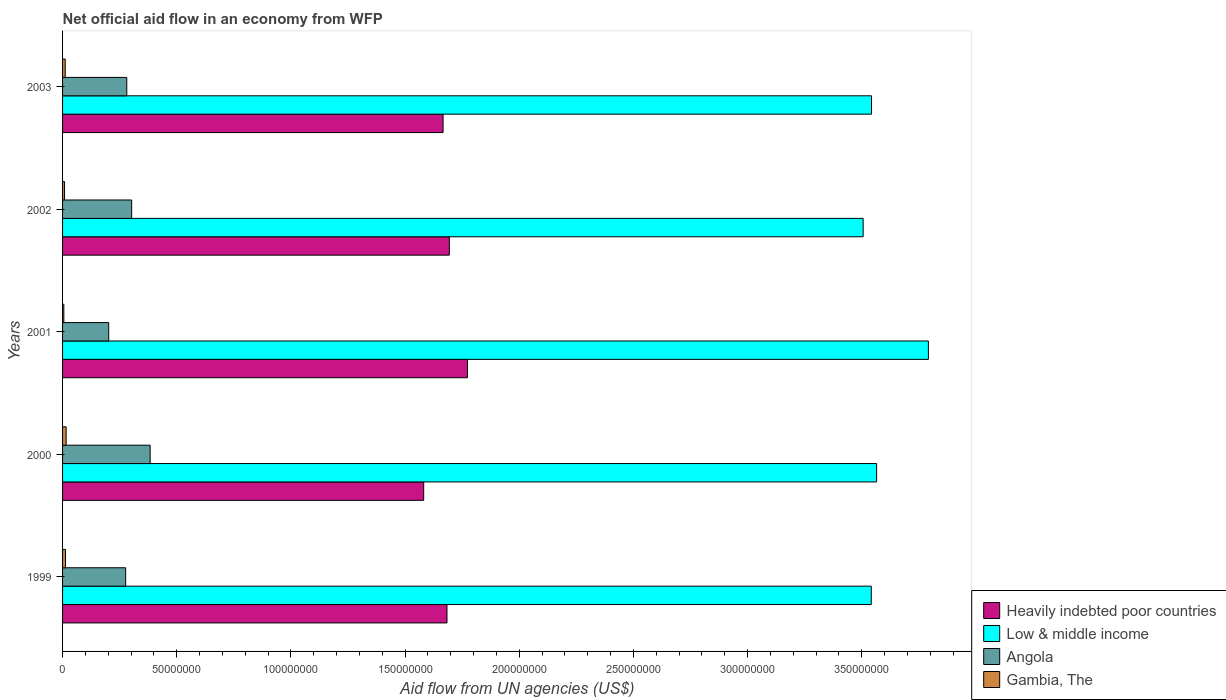How many different coloured bars are there?
Make the answer very short. 4. How many groups of bars are there?
Provide a succinct answer. 5. How many bars are there on the 4th tick from the bottom?
Offer a terse response. 4. In how many cases, is the number of bars for a given year not equal to the number of legend labels?
Your answer should be compact. 0. What is the net official aid flow in Angola in 2001?
Your answer should be very brief. 2.02e+07. Across all years, what is the maximum net official aid flow in Angola?
Give a very brief answer. 3.84e+07. Across all years, what is the minimum net official aid flow in Heavily indebted poor countries?
Your response must be concise. 1.58e+08. In which year was the net official aid flow in Gambia, The maximum?
Ensure brevity in your answer.  2000. In which year was the net official aid flow in Gambia, The minimum?
Provide a short and direct response. 2001. What is the total net official aid flow in Heavily indebted poor countries in the graph?
Offer a very short reply. 8.40e+08. What is the difference between the net official aid flow in Gambia, The in 2002 and that in 2003?
Offer a terse response. -3.00e+05. What is the difference between the net official aid flow in Angola in 2001 and the net official aid flow in Heavily indebted poor countries in 2003?
Give a very brief answer. -1.46e+08. What is the average net official aid flow in Heavily indebted poor countries per year?
Ensure brevity in your answer.  1.68e+08. In the year 2001, what is the difference between the net official aid flow in Heavily indebted poor countries and net official aid flow in Angola?
Your answer should be very brief. 1.57e+08. What is the ratio of the net official aid flow in Angola in 2000 to that in 2002?
Your answer should be compact. 1.27. Is the net official aid flow in Low & middle income in 1999 less than that in 2000?
Your answer should be compact. Yes. Is the difference between the net official aid flow in Heavily indebted poor countries in 1999 and 2002 greater than the difference between the net official aid flow in Angola in 1999 and 2002?
Provide a succinct answer. Yes. What is the difference between the highest and the second highest net official aid flow in Angola?
Your answer should be very brief. 8.10e+06. What is the difference between the highest and the lowest net official aid flow in Angola?
Give a very brief answer. 1.82e+07. In how many years, is the net official aid flow in Gambia, The greater than the average net official aid flow in Gambia, The taken over all years?
Keep it short and to the point. 3. Is the sum of the net official aid flow in Heavily indebted poor countries in 2001 and 2002 greater than the maximum net official aid flow in Low & middle income across all years?
Make the answer very short. No. Is it the case that in every year, the sum of the net official aid flow in Angola and net official aid flow in Gambia, The is greater than the sum of net official aid flow in Heavily indebted poor countries and net official aid flow in Low & middle income?
Your response must be concise. No. What does the 3rd bar from the top in 1999 represents?
Provide a succinct answer. Low & middle income. What does the 4th bar from the bottom in 2001 represents?
Give a very brief answer. Gambia, The. How many bars are there?
Provide a short and direct response. 20. Are all the bars in the graph horizontal?
Your answer should be very brief. Yes. How many years are there in the graph?
Your response must be concise. 5. Are the values on the major ticks of X-axis written in scientific E-notation?
Make the answer very short. No. Does the graph contain grids?
Offer a very short reply. No. Where does the legend appear in the graph?
Ensure brevity in your answer.  Bottom right. What is the title of the graph?
Provide a short and direct response. Net official aid flow in an economy from WFP. Does "Venezuela" appear as one of the legend labels in the graph?
Give a very brief answer. No. What is the label or title of the X-axis?
Your response must be concise. Aid flow from UN agencies (US$). What is the label or title of the Y-axis?
Ensure brevity in your answer.  Years. What is the Aid flow from UN agencies (US$) in Heavily indebted poor countries in 1999?
Offer a terse response. 1.68e+08. What is the Aid flow from UN agencies (US$) in Low & middle income in 1999?
Your answer should be compact. 3.54e+08. What is the Aid flow from UN agencies (US$) of Angola in 1999?
Offer a very short reply. 2.76e+07. What is the Aid flow from UN agencies (US$) of Gambia, The in 1999?
Offer a terse response. 1.29e+06. What is the Aid flow from UN agencies (US$) of Heavily indebted poor countries in 2000?
Provide a short and direct response. 1.58e+08. What is the Aid flow from UN agencies (US$) in Low & middle income in 2000?
Provide a short and direct response. 3.57e+08. What is the Aid flow from UN agencies (US$) in Angola in 2000?
Your response must be concise. 3.84e+07. What is the Aid flow from UN agencies (US$) of Gambia, The in 2000?
Your answer should be very brief. 1.56e+06. What is the Aid flow from UN agencies (US$) in Heavily indebted poor countries in 2001?
Provide a succinct answer. 1.77e+08. What is the Aid flow from UN agencies (US$) of Low & middle income in 2001?
Make the answer very short. 3.79e+08. What is the Aid flow from UN agencies (US$) of Angola in 2001?
Provide a short and direct response. 2.02e+07. What is the Aid flow from UN agencies (US$) in Gambia, The in 2001?
Make the answer very short. 5.60e+05. What is the Aid flow from UN agencies (US$) in Heavily indebted poor countries in 2002?
Give a very brief answer. 1.69e+08. What is the Aid flow from UN agencies (US$) of Low & middle income in 2002?
Ensure brevity in your answer.  3.51e+08. What is the Aid flow from UN agencies (US$) of Angola in 2002?
Your answer should be compact. 3.03e+07. What is the Aid flow from UN agencies (US$) in Gambia, The in 2002?
Your response must be concise. 8.70e+05. What is the Aid flow from UN agencies (US$) of Heavily indebted poor countries in 2003?
Ensure brevity in your answer.  1.67e+08. What is the Aid flow from UN agencies (US$) in Low & middle income in 2003?
Offer a very short reply. 3.54e+08. What is the Aid flow from UN agencies (US$) in Angola in 2003?
Provide a short and direct response. 2.81e+07. What is the Aid flow from UN agencies (US$) of Gambia, The in 2003?
Your response must be concise. 1.17e+06. Across all years, what is the maximum Aid flow from UN agencies (US$) in Heavily indebted poor countries?
Offer a very short reply. 1.77e+08. Across all years, what is the maximum Aid flow from UN agencies (US$) in Low & middle income?
Your answer should be very brief. 3.79e+08. Across all years, what is the maximum Aid flow from UN agencies (US$) of Angola?
Offer a very short reply. 3.84e+07. Across all years, what is the maximum Aid flow from UN agencies (US$) of Gambia, The?
Your answer should be compact. 1.56e+06. Across all years, what is the minimum Aid flow from UN agencies (US$) of Heavily indebted poor countries?
Ensure brevity in your answer.  1.58e+08. Across all years, what is the minimum Aid flow from UN agencies (US$) of Low & middle income?
Your answer should be very brief. 3.51e+08. Across all years, what is the minimum Aid flow from UN agencies (US$) of Angola?
Make the answer very short. 2.02e+07. Across all years, what is the minimum Aid flow from UN agencies (US$) in Gambia, The?
Your answer should be compact. 5.60e+05. What is the total Aid flow from UN agencies (US$) of Heavily indebted poor countries in the graph?
Your answer should be compact. 8.40e+08. What is the total Aid flow from UN agencies (US$) in Low & middle income in the graph?
Offer a terse response. 1.79e+09. What is the total Aid flow from UN agencies (US$) of Angola in the graph?
Give a very brief answer. 1.45e+08. What is the total Aid flow from UN agencies (US$) of Gambia, The in the graph?
Make the answer very short. 5.45e+06. What is the difference between the Aid flow from UN agencies (US$) of Heavily indebted poor countries in 1999 and that in 2000?
Your answer should be compact. 1.02e+07. What is the difference between the Aid flow from UN agencies (US$) of Low & middle income in 1999 and that in 2000?
Your response must be concise. -2.35e+06. What is the difference between the Aid flow from UN agencies (US$) in Angola in 1999 and that in 2000?
Give a very brief answer. -1.07e+07. What is the difference between the Aid flow from UN agencies (US$) in Gambia, The in 1999 and that in 2000?
Your response must be concise. -2.70e+05. What is the difference between the Aid flow from UN agencies (US$) of Heavily indebted poor countries in 1999 and that in 2001?
Your answer should be compact. -8.98e+06. What is the difference between the Aid flow from UN agencies (US$) of Low & middle income in 1999 and that in 2001?
Your answer should be very brief. -2.50e+07. What is the difference between the Aid flow from UN agencies (US$) in Angola in 1999 and that in 2001?
Your response must be concise. 7.41e+06. What is the difference between the Aid flow from UN agencies (US$) of Gambia, The in 1999 and that in 2001?
Your answer should be very brief. 7.30e+05. What is the difference between the Aid flow from UN agencies (US$) of Heavily indebted poor countries in 1999 and that in 2002?
Keep it short and to the point. -1.03e+06. What is the difference between the Aid flow from UN agencies (US$) of Low & middle income in 1999 and that in 2002?
Keep it short and to the point. 3.56e+06. What is the difference between the Aid flow from UN agencies (US$) in Angola in 1999 and that in 2002?
Your response must be concise. -2.64e+06. What is the difference between the Aid flow from UN agencies (US$) in Gambia, The in 1999 and that in 2002?
Offer a very short reply. 4.20e+05. What is the difference between the Aid flow from UN agencies (US$) in Heavily indebted poor countries in 1999 and that in 2003?
Provide a succinct answer. 1.71e+06. What is the difference between the Aid flow from UN agencies (US$) in Angola in 1999 and that in 2003?
Keep it short and to the point. -5.00e+05. What is the difference between the Aid flow from UN agencies (US$) of Gambia, The in 1999 and that in 2003?
Offer a very short reply. 1.20e+05. What is the difference between the Aid flow from UN agencies (US$) in Heavily indebted poor countries in 2000 and that in 2001?
Keep it short and to the point. -1.92e+07. What is the difference between the Aid flow from UN agencies (US$) of Low & middle income in 2000 and that in 2001?
Provide a succinct answer. -2.27e+07. What is the difference between the Aid flow from UN agencies (US$) of Angola in 2000 and that in 2001?
Keep it short and to the point. 1.82e+07. What is the difference between the Aid flow from UN agencies (US$) in Heavily indebted poor countries in 2000 and that in 2002?
Your answer should be compact. -1.12e+07. What is the difference between the Aid flow from UN agencies (US$) of Low & middle income in 2000 and that in 2002?
Your answer should be compact. 5.91e+06. What is the difference between the Aid flow from UN agencies (US$) of Angola in 2000 and that in 2002?
Give a very brief answer. 8.10e+06. What is the difference between the Aid flow from UN agencies (US$) in Gambia, The in 2000 and that in 2002?
Keep it short and to the point. 6.90e+05. What is the difference between the Aid flow from UN agencies (US$) in Heavily indebted poor countries in 2000 and that in 2003?
Ensure brevity in your answer.  -8.49e+06. What is the difference between the Aid flow from UN agencies (US$) in Low & middle income in 2000 and that in 2003?
Your response must be concise. 2.24e+06. What is the difference between the Aid flow from UN agencies (US$) of Angola in 2000 and that in 2003?
Your answer should be compact. 1.02e+07. What is the difference between the Aid flow from UN agencies (US$) of Gambia, The in 2000 and that in 2003?
Your answer should be very brief. 3.90e+05. What is the difference between the Aid flow from UN agencies (US$) of Heavily indebted poor countries in 2001 and that in 2002?
Provide a succinct answer. 7.95e+06. What is the difference between the Aid flow from UN agencies (US$) of Low & middle income in 2001 and that in 2002?
Offer a terse response. 2.86e+07. What is the difference between the Aid flow from UN agencies (US$) of Angola in 2001 and that in 2002?
Provide a succinct answer. -1.00e+07. What is the difference between the Aid flow from UN agencies (US$) in Gambia, The in 2001 and that in 2002?
Provide a short and direct response. -3.10e+05. What is the difference between the Aid flow from UN agencies (US$) in Heavily indebted poor countries in 2001 and that in 2003?
Provide a short and direct response. 1.07e+07. What is the difference between the Aid flow from UN agencies (US$) in Low & middle income in 2001 and that in 2003?
Provide a succinct answer. 2.49e+07. What is the difference between the Aid flow from UN agencies (US$) of Angola in 2001 and that in 2003?
Give a very brief answer. -7.91e+06. What is the difference between the Aid flow from UN agencies (US$) in Gambia, The in 2001 and that in 2003?
Your answer should be compact. -6.10e+05. What is the difference between the Aid flow from UN agencies (US$) of Heavily indebted poor countries in 2002 and that in 2003?
Offer a terse response. 2.74e+06. What is the difference between the Aid flow from UN agencies (US$) of Low & middle income in 2002 and that in 2003?
Ensure brevity in your answer.  -3.67e+06. What is the difference between the Aid flow from UN agencies (US$) of Angola in 2002 and that in 2003?
Your answer should be very brief. 2.14e+06. What is the difference between the Aid flow from UN agencies (US$) of Gambia, The in 2002 and that in 2003?
Ensure brevity in your answer.  -3.00e+05. What is the difference between the Aid flow from UN agencies (US$) in Heavily indebted poor countries in 1999 and the Aid flow from UN agencies (US$) in Low & middle income in 2000?
Your answer should be compact. -1.88e+08. What is the difference between the Aid flow from UN agencies (US$) in Heavily indebted poor countries in 1999 and the Aid flow from UN agencies (US$) in Angola in 2000?
Provide a succinct answer. 1.30e+08. What is the difference between the Aid flow from UN agencies (US$) in Heavily indebted poor countries in 1999 and the Aid flow from UN agencies (US$) in Gambia, The in 2000?
Your answer should be compact. 1.67e+08. What is the difference between the Aid flow from UN agencies (US$) of Low & middle income in 1999 and the Aid flow from UN agencies (US$) of Angola in 2000?
Give a very brief answer. 3.16e+08. What is the difference between the Aid flow from UN agencies (US$) in Low & middle income in 1999 and the Aid flow from UN agencies (US$) in Gambia, The in 2000?
Keep it short and to the point. 3.53e+08. What is the difference between the Aid flow from UN agencies (US$) of Angola in 1999 and the Aid flow from UN agencies (US$) of Gambia, The in 2000?
Offer a very short reply. 2.61e+07. What is the difference between the Aid flow from UN agencies (US$) of Heavily indebted poor countries in 1999 and the Aid flow from UN agencies (US$) of Low & middle income in 2001?
Offer a very short reply. -2.11e+08. What is the difference between the Aid flow from UN agencies (US$) of Heavily indebted poor countries in 1999 and the Aid flow from UN agencies (US$) of Angola in 2001?
Provide a short and direct response. 1.48e+08. What is the difference between the Aid flow from UN agencies (US$) of Heavily indebted poor countries in 1999 and the Aid flow from UN agencies (US$) of Gambia, The in 2001?
Your response must be concise. 1.68e+08. What is the difference between the Aid flow from UN agencies (US$) of Low & middle income in 1999 and the Aid flow from UN agencies (US$) of Angola in 2001?
Keep it short and to the point. 3.34e+08. What is the difference between the Aid flow from UN agencies (US$) of Low & middle income in 1999 and the Aid flow from UN agencies (US$) of Gambia, The in 2001?
Offer a very short reply. 3.54e+08. What is the difference between the Aid flow from UN agencies (US$) in Angola in 1999 and the Aid flow from UN agencies (US$) in Gambia, The in 2001?
Your answer should be compact. 2.71e+07. What is the difference between the Aid flow from UN agencies (US$) of Heavily indebted poor countries in 1999 and the Aid flow from UN agencies (US$) of Low & middle income in 2002?
Your response must be concise. -1.82e+08. What is the difference between the Aid flow from UN agencies (US$) in Heavily indebted poor countries in 1999 and the Aid flow from UN agencies (US$) in Angola in 2002?
Give a very brief answer. 1.38e+08. What is the difference between the Aid flow from UN agencies (US$) of Heavily indebted poor countries in 1999 and the Aid flow from UN agencies (US$) of Gambia, The in 2002?
Offer a very short reply. 1.67e+08. What is the difference between the Aid flow from UN agencies (US$) of Low & middle income in 1999 and the Aid flow from UN agencies (US$) of Angola in 2002?
Ensure brevity in your answer.  3.24e+08. What is the difference between the Aid flow from UN agencies (US$) in Low & middle income in 1999 and the Aid flow from UN agencies (US$) in Gambia, The in 2002?
Provide a succinct answer. 3.53e+08. What is the difference between the Aid flow from UN agencies (US$) in Angola in 1999 and the Aid flow from UN agencies (US$) in Gambia, The in 2002?
Make the answer very short. 2.68e+07. What is the difference between the Aid flow from UN agencies (US$) in Heavily indebted poor countries in 1999 and the Aid flow from UN agencies (US$) in Low & middle income in 2003?
Your answer should be compact. -1.86e+08. What is the difference between the Aid flow from UN agencies (US$) in Heavily indebted poor countries in 1999 and the Aid flow from UN agencies (US$) in Angola in 2003?
Offer a very short reply. 1.40e+08. What is the difference between the Aid flow from UN agencies (US$) of Heavily indebted poor countries in 1999 and the Aid flow from UN agencies (US$) of Gambia, The in 2003?
Provide a succinct answer. 1.67e+08. What is the difference between the Aid flow from UN agencies (US$) in Low & middle income in 1999 and the Aid flow from UN agencies (US$) in Angola in 2003?
Keep it short and to the point. 3.26e+08. What is the difference between the Aid flow from UN agencies (US$) of Low & middle income in 1999 and the Aid flow from UN agencies (US$) of Gambia, The in 2003?
Offer a very short reply. 3.53e+08. What is the difference between the Aid flow from UN agencies (US$) in Angola in 1999 and the Aid flow from UN agencies (US$) in Gambia, The in 2003?
Your answer should be very brief. 2.64e+07. What is the difference between the Aid flow from UN agencies (US$) in Heavily indebted poor countries in 2000 and the Aid flow from UN agencies (US$) in Low & middle income in 2001?
Provide a succinct answer. -2.21e+08. What is the difference between the Aid flow from UN agencies (US$) of Heavily indebted poor countries in 2000 and the Aid flow from UN agencies (US$) of Angola in 2001?
Offer a terse response. 1.38e+08. What is the difference between the Aid flow from UN agencies (US$) in Heavily indebted poor countries in 2000 and the Aid flow from UN agencies (US$) in Gambia, The in 2001?
Give a very brief answer. 1.58e+08. What is the difference between the Aid flow from UN agencies (US$) in Low & middle income in 2000 and the Aid flow from UN agencies (US$) in Angola in 2001?
Provide a succinct answer. 3.36e+08. What is the difference between the Aid flow from UN agencies (US$) of Low & middle income in 2000 and the Aid flow from UN agencies (US$) of Gambia, The in 2001?
Offer a very short reply. 3.56e+08. What is the difference between the Aid flow from UN agencies (US$) of Angola in 2000 and the Aid flow from UN agencies (US$) of Gambia, The in 2001?
Your answer should be very brief. 3.78e+07. What is the difference between the Aid flow from UN agencies (US$) in Heavily indebted poor countries in 2000 and the Aid flow from UN agencies (US$) in Low & middle income in 2002?
Ensure brevity in your answer.  -1.92e+08. What is the difference between the Aid flow from UN agencies (US$) in Heavily indebted poor countries in 2000 and the Aid flow from UN agencies (US$) in Angola in 2002?
Provide a succinct answer. 1.28e+08. What is the difference between the Aid flow from UN agencies (US$) of Heavily indebted poor countries in 2000 and the Aid flow from UN agencies (US$) of Gambia, The in 2002?
Offer a very short reply. 1.57e+08. What is the difference between the Aid flow from UN agencies (US$) of Low & middle income in 2000 and the Aid flow from UN agencies (US$) of Angola in 2002?
Ensure brevity in your answer.  3.26e+08. What is the difference between the Aid flow from UN agencies (US$) of Low & middle income in 2000 and the Aid flow from UN agencies (US$) of Gambia, The in 2002?
Your answer should be very brief. 3.56e+08. What is the difference between the Aid flow from UN agencies (US$) in Angola in 2000 and the Aid flow from UN agencies (US$) in Gambia, The in 2002?
Give a very brief answer. 3.75e+07. What is the difference between the Aid flow from UN agencies (US$) of Heavily indebted poor countries in 2000 and the Aid flow from UN agencies (US$) of Low & middle income in 2003?
Your response must be concise. -1.96e+08. What is the difference between the Aid flow from UN agencies (US$) in Heavily indebted poor countries in 2000 and the Aid flow from UN agencies (US$) in Angola in 2003?
Make the answer very short. 1.30e+08. What is the difference between the Aid flow from UN agencies (US$) in Heavily indebted poor countries in 2000 and the Aid flow from UN agencies (US$) in Gambia, The in 2003?
Offer a very short reply. 1.57e+08. What is the difference between the Aid flow from UN agencies (US$) of Low & middle income in 2000 and the Aid flow from UN agencies (US$) of Angola in 2003?
Keep it short and to the point. 3.28e+08. What is the difference between the Aid flow from UN agencies (US$) of Low & middle income in 2000 and the Aid flow from UN agencies (US$) of Gambia, The in 2003?
Give a very brief answer. 3.55e+08. What is the difference between the Aid flow from UN agencies (US$) in Angola in 2000 and the Aid flow from UN agencies (US$) in Gambia, The in 2003?
Provide a short and direct response. 3.72e+07. What is the difference between the Aid flow from UN agencies (US$) of Heavily indebted poor countries in 2001 and the Aid flow from UN agencies (US$) of Low & middle income in 2002?
Make the answer very short. -1.73e+08. What is the difference between the Aid flow from UN agencies (US$) in Heavily indebted poor countries in 2001 and the Aid flow from UN agencies (US$) in Angola in 2002?
Offer a very short reply. 1.47e+08. What is the difference between the Aid flow from UN agencies (US$) in Heavily indebted poor countries in 2001 and the Aid flow from UN agencies (US$) in Gambia, The in 2002?
Give a very brief answer. 1.76e+08. What is the difference between the Aid flow from UN agencies (US$) of Low & middle income in 2001 and the Aid flow from UN agencies (US$) of Angola in 2002?
Provide a succinct answer. 3.49e+08. What is the difference between the Aid flow from UN agencies (US$) of Low & middle income in 2001 and the Aid flow from UN agencies (US$) of Gambia, The in 2002?
Your answer should be very brief. 3.78e+08. What is the difference between the Aid flow from UN agencies (US$) of Angola in 2001 and the Aid flow from UN agencies (US$) of Gambia, The in 2002?
Offer a terse response. 1.93e+07. What is the difference between the Aid flow from UN agencies (US$) in Heavily indebted poor countries in 2001 and the Aid flow from UN agencies (US$) in Low & middle income in 2003?
Offer a terse response. -1.77e+08. What is the difference between the Aid flow from UN agencies (US$) of Heavily indebted poor countries in 2001 and the Aid flow from UN agencies (US$) of Angola in 2003?
Give a very brief answer. 1.49e+08. What is the difference between the Aid flow from UN agencies (US$) in Heavily indebted poor countries in 2001 and the Aid flow from UN agencies (US$) in Gambia, The in 2003?
Give a very brief answer. 1.76e+08. What is the difference between the Aid flow from UN agencies (US$) in Low & middle income in 2001 and the Aid flow from UN agencies (US$) in Angola in 2003?
Provide a succinct answer. 3.51e+08. What is the difference between the Aid flow from UN agencies (US$) of Low & middle income in 2001 and the Aid flow from UN agencies (US$) of Gambia, The in 2003?
Your answer should be compact. 3.78e+08. What is the difference between the Aid flow from UN agencies (US$) of Angola in 2001 and the Aid flow from UN agencies (US$) of Gambia, The in 2003?
Ensure brevity in your answer.  1.90e+07. What is the difference between the Aid flow from UN agencies (US$) of Heavily indebted poor countries in 2002 and the Aid flow from UN agencies (US$) of Low & middle income in 2003?
Your response must be concise. -1.85e+08. What is the difference between the Aid flow from UN agencies (US$) of Heavily indebted poor countries in 2002 and the Aid flow from UN agencies (US$) of Angola in 2003?
Your answer should be very brief. 1.41e+08. What is the difference between the Aid flow from UN agencies (US$) in Heavily indebted poor countries in 2002 and the Aid flow from UN agencies (US$) in Gambia, The in 2003?
Offer a terse response. 1.68e+08. What is the difference between the Aid flow from UN agencies (US$) in Low & middle income in 2002 and the Aid flow from UN agencies (US$) in Angola in 2003?
Provide a short and direct response. 3.22e+08. What is the difference between the Aid flow from UN agencies (US$) in Low & middle income in 2002 and the Aid flow from UN agencies (US$) in Gambia, The in 2003?
Ensure brevity in your answer.  3.49e+08. What is the difference between the Aid flow from UN agencies (US$) in Angola in 2002 and the Aid flow from UN agencies (US$) in Gambia, The in 2003?
Your response must be concise. 2.91e+07. What is the average Aid flow from UN agencies (US$) in Heavily indebted poor countries per year?
Make the answer very short. 1.68e+08. What is the average Aid flow from UN agencies (US$) of Low & middle income per year?
Keep it short and to the point. 3.59e+08. What is the average Aid flow from UN agencies (US$) in Angola per year?
Ensure brevity in your answer.  2.89e+07. What is the average Aid flow from UN agencies (US$) of Gambia, The per year?
Offer a terse response. 1.09e+06. In the year 1999, what is the difference between the Aid flow from UN agencies (US$) of Heavily indebted poor countries and Aid flow from UN agencies (US$) of Low & middle income?
Ensure brevity in your answer.  -1.86e+08. In the year 1999, what is the difference between the Aid flow from UN agencies (US$) in Heavily indebted poor countries and Aid flow from UN agencies (US$) in Angola?
Offer a very short reply. 1.41e+08. In the year 1999, what is the difference between the Aid flow from UN agencies (US$) of Heavily indebted poor countries and Aid flow from UN agencies (US$) of Gambia, The?
Your answer should be compact. 1.67e+08. In the year 1999, what is the difference between the Aid flow from UN agencies (US$) of Low & middle income and Aid flow from UN agencies (US$) of Angola?
Give a very brief answer. 3.27e+08. In the year 1999, what is the difference between the Aid flow from UN agencies (US$) of Low & middle income and Aid flow from UN agencies (US$) of Gambia, The?
Ensure brevity in your answer.  3.53e+08. In the year 1999, what is the difference between the Aid flow from UN agencies (US$) of Angola and Aid flow from UN agencies (US$) of Gambia, The?
Make the answer very short. 2.63e+07. In the year 2000, what is the difference between the Aid flow from UN agencies (US$) in Heavily indebted poor countries and Aid flow from UN agencies (US$) in Low & middle income?
Offer a terse response. -1.98e+08. In the year 2000, what is the difference between the Aid flow from UN agencies (US$) in Heavily indebted poor countries and Aid flow from UN agencies (US$) in Angola?
Offer a terse response. 1.20e+08. In the year 2000, what is the difference between the Aid flow from UN agencies (US$) of Heavily indebted poor countries and Aid flow from UN agencies (US$) of Gambia, The?
Provide a short and direct response. 1.57e+08. In the year 2000, what is the difference between the Aid flow from UN agencies (US$) in Low & middle income and Aid flow from UN agencies (US$) in Angola?
Make the answer very short. 3.18e+08. In the year 2000, what is the difference between the Aid flow from UN agencies (US$) in Low & middle income and Aid flow from UN agencies (US$) in Gambia, The?
Provide a succinct answer. 3.55e+08. In the year 2000, what is the difference between the Aid flow from UN agencies (US$) in Angola and Aid flow from UN agencies (US$) in Gambia, The?
Offer a very short reply. 3.68e+07. In the year 2001, what is the difference between the Aid flow from UN agencies (US$) in Heavily indebted poor countries and Aid flow from UN agencies (US$) in Low & middle income?
Ensure brevity in your answer.  -2.02e+08. In the year 2001, what is the difference between the Aid flow from UN agencies (US$) in Heavily indebted poor countries and Aid flow from UN agencies (US$) in Angola?
Your answer should be compact. 1.57e+08. In the year 2001, what is the difference between the Aid flow from UN agencies (US$) in Heavily indebted poor countries and Aid flow from UN agencies (US$) in Gambia, The?
Your answer should be very brief. 1.77e+08. In the year 2001, what is the difference between the Aid flow from UN agencies (US$) in Low & middle income and Aid flow from UN agencies (US$) in Angola?
Ensure brevity in your answer.  3.59e+08. In the year 2001, what is the difference between the Aid flow from UN agencies (US$) of Low & middle income and Aid flow from UN agencies (US$) of Gambia, The?
Your answer should be compact. 3.79e+08. In the year 2001, what is the difference between the Aid flow from UN agencies (US$) of Angola and Aid flow from UN agencies (US$) of Gambia, The?
Your answer should be very brief. 1.96e+07. In the year 2002, what is the difference between the Aid flow from UN agencies (US$) in Heavily indebted poor countries and Aid flow from UN agencies (US$) in Low & middle income?
Your response must be concise. -1.81e+08. In the year 2002, what is the difference between the Aid flow from UN agencies (US$) of Heavily indebted poor countries and Aid flow from UN agencies (US$) of Angola?
Your answer should be very brief. 1.39e+08. In the year 2002, what is the difference between the Aid flow from UN agencies (US$) of Heavily indebted poor countries and Aid flow from UN agencies (US$) of Gambia, The?
Provide a short and direct response. 1.69e+08. In the year 2002, what is the difference between the Aid flow from UN agencies (US$) in Low & middle income and Aid flow from UN agencies (US$) in Angola?
Give a very brief answer. 3.20e+08. In the year 2002, what is the difference between the Aid flow from UN agencies (US$) of Low & middle income and Aid flow from UN agencies (US$) of Gambia, The?
Give a very brief answer. 3.50e+08. In the year 2002, what is the difference between the Aid flow from UN agencies (US$) in Angola and Aid flow from UN agencies (US$) in Gambia, The?
Provide a short and direct response. 2.94e+07. In the year 2003, what is the difference between the Aid flow from UN agencies (US$) of Heavily indebted poor countries and Aid flow from UN agencies (US$) of Low & middle income?
Offer a terse response. -1.88e+08. In the year 2003, what is the difference between the Aid flow from UN agencies (US$) of Heavily indebted poor countries and Aid flow from UN agencies (US$) of Angola?
Your answer should be compact. 1.39e+08. In the year 2003, what is the difference between the Aid flow from UN agencies (US$) in Heavily indebted poor countries and Aid flow from UN agencies (US$) in Gambia, The?
Keep it short and to the point. 1.65e+08. In the year 2003, what is the difference between the Aid flow from UN agencies (US$) in Low & middle income and Aid flow from UN agencies (US$) in Angola?
Offer a terse response. 3.26e+08. In the year 2003, what is the difference between the Aid flow from UN agencies (US$) in Low & middle income and Aid flow from UN agencies (US$) in Gambia, The?
Provide a succinct answer. 3.53e+08. In the year 2003, what is the difference between the Aid flow from UN agencies (US$) of Angola and Aid flow from UN agencies (US$) of Gambia, The?
Give a very brief answer. 2.70e+07. What is the ratio of the Aid flow from UN agencies (US$) in Heavily indebted poor countries in 1999 to that in 2000?
Your response must be concise. 1.06. What is the ratio of the Aid flow from UN agencies (US$) in Low & middle income in 1999 to that in 2000?
Your response must be concise. 0.99. What is the ratio of the Aid flow from UN agencies (US$) in Angola in 1999 to that in 2000?
Your response must be concise. 0.72. What is the ratio of the Aid flow from UN agencies (US$) of Gambia, The in 1999 to that in 2000?
Give a very brief answer. 0.83. What is the ratio of the Aid flow from UN agencies (US$) of Heavily indebted poor countries in 1999 to that in 2001?
Ensure brevity in your answer.  0.95. What is the ratio of the Aid flow from UN agencies (US$) in Low & middle income in 1999 to that in 2001?
Make the answer very short. 0.93. What is the ratio of the Aid flow from UN agencies (US$) of Angola in 1999 to that in 2001?
Your answer should be very brief. 1.37. What is the ratio of the Aid flow from UN agencies (US$) of Gambia, The in 1999 to that in 2001?
Offer a terse response. 2.3. What is the ratio of the Aid flow from UN agencies (US$) of Low & middle income in 1999 to that in 2002?
Make the answer very short. 1.01. What is the ratio of the Aid flow from UN agencies (US$) in Angola in 1999 to that in 2002?
Your response must be concise. 0.91. What is the ratio of the Aid flow from UN agencies (US$) in Gambia, The in 1999 to that in 2002?
Offer a very short reply. 1.48. What is the ratio of the Aid flow from UN agencies (US$) of Heavily indebted poor countries in 1999 to that in 2003?
Provide a succinct answer. 1.01. What is the ratio of the Aid flow from UN agencies (US$) of Angola in 1999 to that in 2003?
Your response must be concise. 0.98. What is the ratio of the Aid flow from UN agencies (US$) of Gambia, The in 1999 to that in 2003?
Your answer should be compact. 1.1. What is the ratio of the Aid flow from UN agencies (US$) of Heavily indebted poor countries in 2000 to that in 2001?
Provide a succinct answer. 0.89. What is the ratio of the Aid flow from UN agencies (US$) in Low & middle income in 2000 to that in 2001?
Your answer should be very brief. 0.94. What is the ratio of the Aid flow from UN agencies (US$) of Angola in 2000 to that in 2001?
Offer a terse response. 1.9. What is the ratio of the Aid flow from UN agencies (US$) of Gambia, The in 2000 to that in 2001?
Provide a short and direct response. 2.79. What is the ratio of the Aid flow from UN agencies (US$) in Heavily indebted poor countries in 2000 to that in 2002?
Give a very brief answer. 0.93. What is the ratio of the Aid flow from UN agencies (US$) of Low & middle income in 2000 to that in 2002?
Your response must be concise. 1.02. What is the ratio of the Aid flow from UN agencies (US$) of Angola in 2000 to that in 2002?
Ensure brevity in your answer.  1.27. What is the ratio of the Aid flow from UN agencies (US$) of Gambia, The in 2000 to that in 2002?
Your response must be concise. 1.79. What is the ratio of the Aid flow from UN agencies (US$) of Heavily indebted poor countries in 2000 to that in 2003?
Your answer should be very brief. 0.95. What is the ratio of the Aid flow from UN agencies (US$) of Low & middle income in 2000 to that in 2003?
Your answer should be compact. 1.01. What is the ratio of the Aid flow from UN agencies (US$) of Angola in 2000 to that in 2003?
Provide a succinct answer. 1.36. What is the ratio of the Aid flow from UN agencies (US$) in Heavily indebted poor countries in 2001 to that in 2002?
Offer a very short reply. 1.05. What is the ratio of the Aid flow from UN agencies (US$) of Low & middle income in 2001 to that in 2002?
Offer a terse response. 1.08. What is the ratio of the Aid flow from UN agencies (US$) in Angola in 2001 to that in 2002?
Give a very brief answer. 0.67. What is the ratio of the Aid flow from UN agencies (US$) in Gambia, The in 2001 to that in 2002?
Offer a terse response. 0.64. What is the ratio of the Aid flow from UN agencies (US$) in Heavily indebted poor countries in 2001 to that in 2003?
Provide a succinct answer. 1.06. What is the ratio of the Aid flow from UN agencies (US$) in Low & middle income in 2001 to that in 2003?
Offer a terse response. 1.07. What is the ratio of the Aid flow from UN agencies (US$) of Angola in 2001 to that in 2003?
Your response must be concise. 0.72. What is the ratio of the Aid flow from UN agencies (US$) in Gambia, The in 2001 to that in 2003?
Your answer should be very brief. 0.48. What is the ratio of the Aid flow from UN agencies (US$) of Heavily indebted poor countries in 2002 to that in 2003?
Your answer should be very brief. 1.02. What is the ratio of the Aid flow from UN agencies (US$) in Angola in 2002 to that in 2003?
Give a very brief answer. 1.08. What is the ratio of the Aid flow from UN agencies (US$) in Gambia, The in 2002 to that in 2003?
Make the answer very short. 0.74. What is the difference between the highest and the second highest Aid flow from UN agencies (US$) of Heavily indebted poor countries?
Keep it short and to the point. 7.95e+06. What is the difference between the highest and the second highest Aid flow from UN agencies (US$) in Low & middle income?
Offer a very short reply. 2.27e+07. What is the difference between the highest and the second highest Aid flow from UN agencies (US$) in Angola?
Offer a terse response. 8.10e+06. What is the difference between the highest and the second highest Aid flow from UN agencies (US$) of Gambia, The?
Keep it short and to the point. 2.70e+05. What is the difference between the highest and the lowest Aid flow from UN agencies (US$) in Heavily indebted poor countries?
Your response must be concise. 1.92e+07. What is the difference between the highest and the lowest Aid flow from UN agencies (US$) of Low & middle income?
Your answer should be very brief. 2.86e+07. What is the difference between the highest and the lowest Aid flow from UN agencies (US$) in Angola?
Offer a terse response. 1.82e+07. 